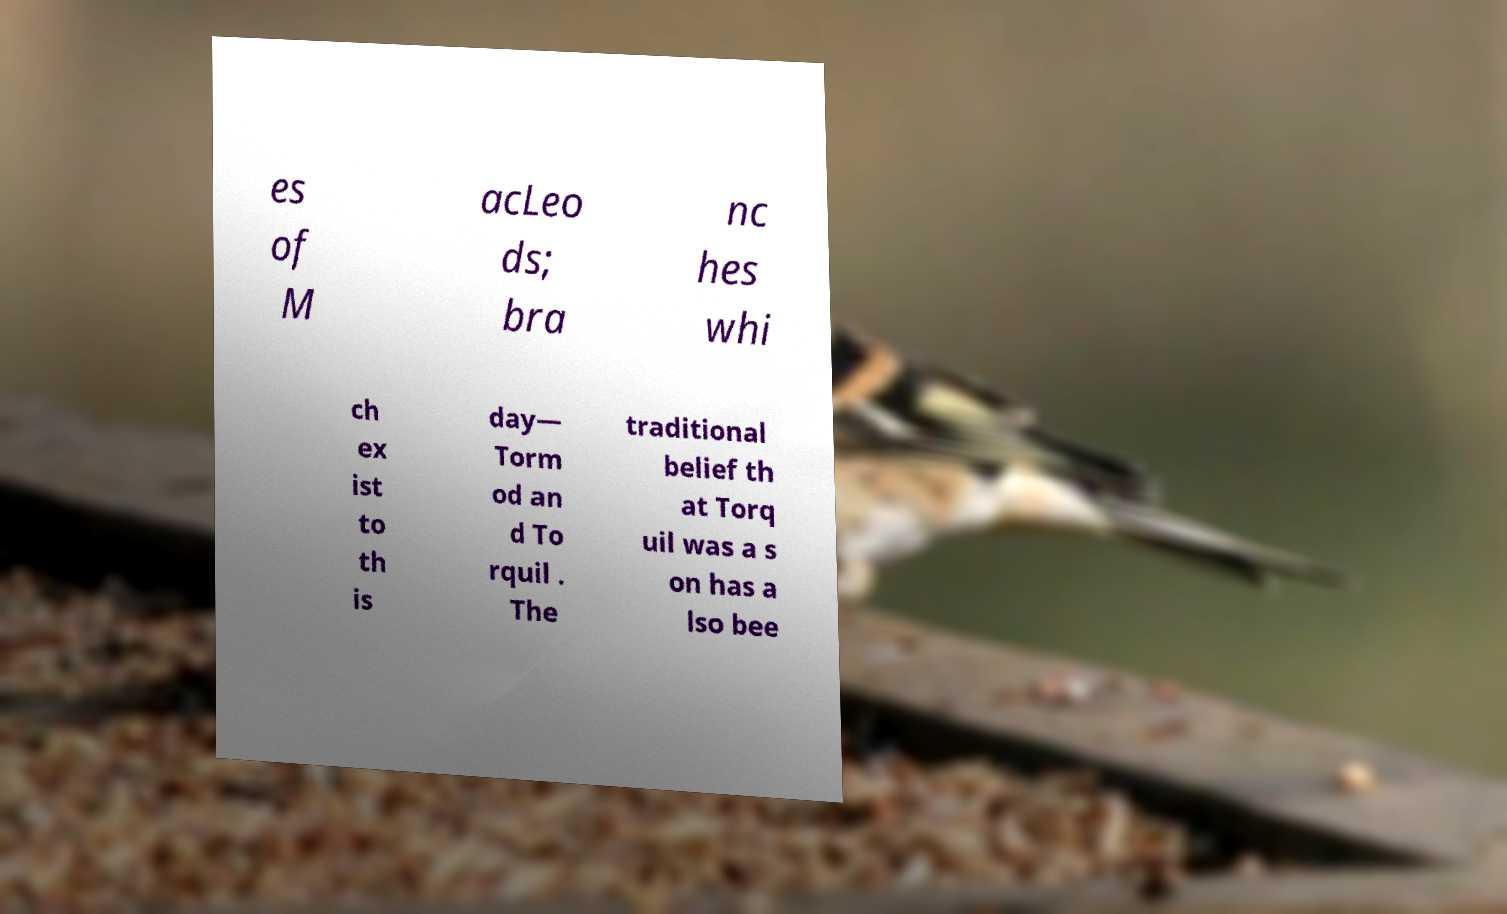Could you extract and type out the text from this image? es of M acLeo ds; bra nc hes whi ch ex ist to th is day— Torm od an d To rquil . The traditional belief th at Torq uil was a s on has a lso bee 